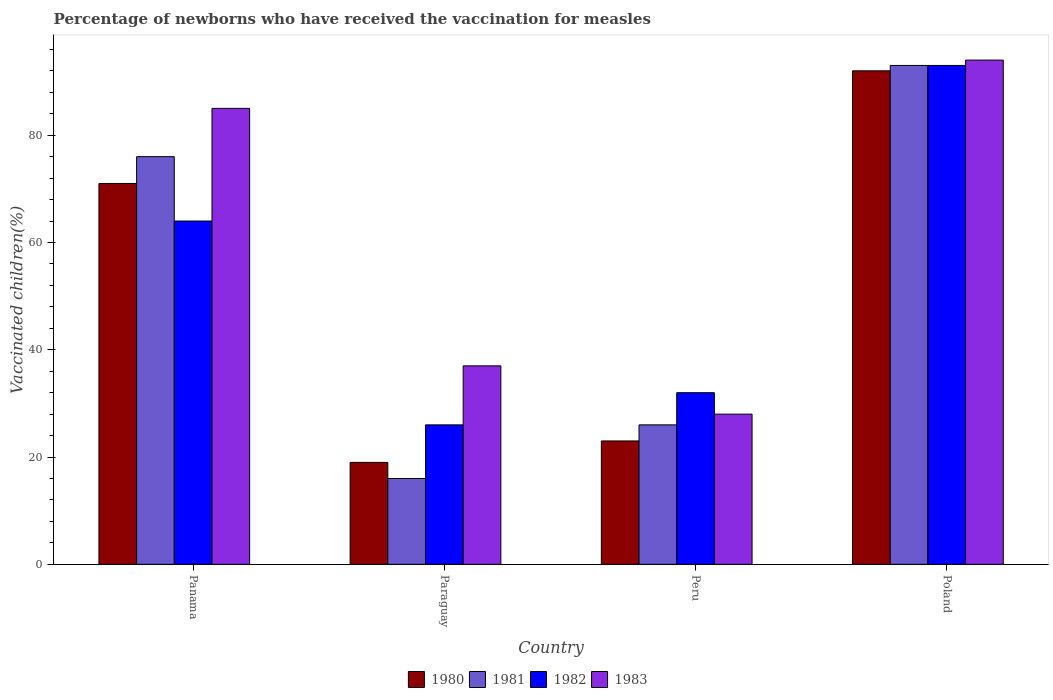How many groups of bars are there?
Your answer should be very brief. 4. Are the number of bars per tick equal to the number of legend labels?
Make the answer very short. Yes. How many bars are there on the 1st tick from the left?
Ensure brevity in your answer.  4. What is the label of the 2nd group of bars from the left?
Offer a terse response. Paraguay. In how many cases, is the number of bars for a given country not equal to the number of legend labels?
Offer a very short reply. 0. What is the percentage of vaccinated children in 1983 in Poland?
Your response must be concise. 94. Across all countries, what is the maximum percentage of vaccinated children in 1981?
Your answer should be very brief. 93. In which country was the percentage of vaccinated children in 1982 minimum?
Make the answer very short. Paraguay. What is the total percentage of vaccinated children in 1980 in the graph?
Your answer should be very brief. 205. What is the difference between the percentage of vaccinated children in 1980 in Panama and that in Peru?
Keep it short and to the point. 48. What is the difference between the percentage of vaccinated children in 1980 in Peru and the percentage of vaccinated children in 1983 in Poland?
Your response must be concise. -71. What is the difference between the percentage of vaccinated children of/in 1981 and percentage of vaccinated children of/in 1983 in Peru?
Make the answer very short. -2. In how many countries, is the percentage of vaccinated children in 1980 greater than 28 %?
Ensure brevity in your answer.  2. What is the ratio of the percentage of vaccinated children in 1980 in Panama to that in Peru?
Keep it short and to the point. 3.09. Is the difference between the percentage of vaccinated children in 1981 in Paraguay and Peru greater than the difference between the percentage of vaccinated children in 1983 in Paraguay and Peru?
Give a very brief answer. No. Is the sum of the percentage of vaccinated children in 1980 in Panama and Peru greater than the maximum percentage of vaccinated children in 1981 across all countries?
Provide a short and direct response. Yes. What does the 3rd bar from the left in Poland represents?
Make the answer very short. 1982. What does the 3rd bar from the right in Peru represents?
Your response must be concise. 1981. Is it the case that in every country, the sum of the percentage of vaccinated children in 1980 and percentage of vaccinated children in 1983 is greater than the percentage of vaccinated children in 1982?
Provide a short and direct response. Yes. How many bars are there?
Make the answer very short. 16. How many countries are there in the graph?
Offer a very short reply. 4. Are the values on the major ticks of Y-axis written in scientific E-notation?
Make the answer very short. No. How many legend labels are there?
Your response must be concise. 4. How are the legend labels stacked?
Offer a terse response. Horizontal. What is the title of the graph?
Give a very brief answer. Percentage of newborns who have received the vaccination for measles. What is the label or title of the Y-axis?
Offer a terse response. Vaccinated children(%). What is the Vaccinated children(%) in 1982 in Paraguay?
Offer a terse response. 26. What is the Vaccinated children(%) of 1980 in Peru?
Your answer should be compact. 23. What is the Vaccinated children(%) in 1981 in Peru?
Your response must be concise. 26. What is the Vaccinated children(%) of 1982 in Peru?
Give a very brief answer. 32. What is the Vaccinated children(%) in 1983 in Peru?
Offer a terse response. 28. What is the Vaccinated children(%) of 1980 in Poland?
Your answer should be very brief. 92. What is the Vaccinated children(%) of 1981 in Poland?
Provide a short and direct response. 93. What is the Vaccinated children(%) in 1982 in Poland?
Offer a terse response. 93. What is the Vaccinated children(%) of 1983 in Poland?
Your response must be concise. 94. Across all countries, what is the maximum Vaccinated children(%) in 1980?
Give a very brief answer. 92. Across all countries, what is the maximum Vaccinated children(%) in 1981?
Offer a terse response. 93. Across all countries, what is the maximum Vaccinated children(%) of 1982?
Your response must be concise. 93. Across all countries, what is the maximum Vaccinated children(%) of 1983?
Keep it short and to the point. 94. Across all countries, what is the minimum Vaccinated children(%) of 1981?
Offer a very short reply. 16. Across all countries, what is the minimum Vaccinated children(%) of 1982?
Your answer should be very brief. 26. Across all countries, what is the minimum Vaccinated children(%) of 1983?
Offer a very short reply. 28. What is the total Vaccinated children(%) in 1980 in the graph?
Make the answer very short. 205. What is the total Vaccinated children(%) in 1981 in the graph?
Offer a very short reply. 211. What is the total Vaccinated children(%) in 1982 in the graph?
Provide a short and direct response. 215. What is the total Vaccinated children(%) in 1983 in the graph?
Ensure brevity in your answer.  244. What is the difference between the Vaccinated children(%) of 1980 in Panama and that in Paraguay?
Provide a succinct answer. 52. What is the difference between the Vaccinated children(%) in 1982 in Panama and that in Paraguay?
Offer a very short reply. 38. What is the difference between the Vaccinated children(%) of 1980 in Panama and that in Peru?
Make the answer very short. 48. What is the difference between the Vaccinated children(%) in 1981 in Panama and that in Poland?
Your response must be concise. -17. What is the difference between the Vaccinated children(%) in 1983 in Panama and that in Poland?
Your answer should be very brief. -9. What is the difference between the Vaccinated children(%) in 1980 in Paraguay and that in Peru?
Keep it short and to the point. -4. What is the difference between the Vaccinated children(%) in 1981 in Paraguay and that in Peru?
Provide a succinct answer. -10. What is the difference between the Vaccinated children(%) in 1982 in Paraguay and that in Peru?
Your answer should be compact. -6. What is the difference between the Vaccinated children(%) in 1983 in Paraguay and that in Peru?
Ensure brevity in your answer.  9. What is the difference between the Vaccinated children(%) of 1980 in Paraguay and that in Poland?
Your answer should be compact. -73. What is the difference between the Vaccinated children(%) in 1981 in Paraguay and that in Poland?
Offer a very short reply. -77. What is the difference between the Vaccinated children(%) of 1982 in Paraguay and that in Poland?
Provide a short and direct response. -67. What is the difference between the Vaccinated children(%) of 1983 in Paraguay and that in Poland?
Give a very brief answer. -57. What is the difference between the Vaccinated children(%) of 1980 in Peru and that in Poland?
Provide a short and direct response. -69. What is the difference between the Vaccinated children(%) in 1981 in Peru and that in Poland?
Keep it short and to the point. -67. What is the difference between the Vaccinated children(%) in 1982 in Peru and that in Poland?
Your answer should be compact. -61. What is the difference between the Vaccinated children(%) in 1983 in Peru and that in Poland?
Ensure brevity in your answer.  -66. What is the difference between the Vaccinated children(%) in 1980 in Panama and the Vaccinated children(%) in 1981 in Paraguay?
Offer a terse response. 55. What is the difference between the Vaccinated children(%) of 1980 in Panama and the Vaccinated children(%) of 1982 in Paraguay?
Offer a very short reply. 45. What is the difference between the Vaccinated children(%) of 1981 in Panama and the Vaccinated children(%) of 1983 in Paraguay?
Make the answer very short. 39. What is the difference between the Vaccinated children(%) of 1982 in Panama and the Vaccinated children(%) of 1983 in Paraguay?
Your answer should be compact. 27. What is the difference between the Vaccinated children(%) in 1980 in Panama and the Vaccinated children(%) in 1982 in Peru?
Offer a very short reply. 39. What is the difference between the Vaccinated children(%) in 1981 in Panama and the Vaccinated children(%) in 1982 in Peru?
Provide a succinct answer. 44. What is the difference between the Vaccinated children(%) in 1980 in Panama and the Vaccinated children(%) in 1983 in Poland?
Keep it short and to the point. -23. What is the difference between the Vaccinated children(%) in 1981 in Panama and the Vaccinated children(%) in 1982 in Poland?
Your response must be concise. -17. What is the difference between the Vaccinated children(%) of 1981 in Panama and the Vaccinated children(%) of 1983 in Poland?
Your answer should be compact. -18. What is the difference between the Vaccinated children(%) in 1982 in Panama and the Vaccinated children(%) in 1983 in Poland?
Your answer should be compact. -30. What is the difference between the Vaccinated children(%) of 1980 in Paraguay and the Vaccinated children(%) of 1981 in Peru?
Your answer should be very brief. -7. What is the difference between the Vaccinated children(%) of 1981 in Paraguay and the Vaccinated children(%) of 1982 in Peru?
Give a very brief answer. -16. What is the difference between the Vaccinated children(%) in 1981 in Paraguay and the Vaccinated children(%) in 1983 in Peru?
Your answer should be compact. -12. What is the difference between the Vaccinated children(%) of 1980 in Paraguay and the Vaccinated children(%) of 1981 in Poland?
Give a very brief answer. -74. What is the difference between the Vaccinated children(%) of 1980 in Paraguay and the Vaccinated children(%) of 1982 in Poland?
Give a very brief answer. -74. What is the difference between the Vaccinated children(%) of 1980 in Paraguay and the Vaccinated children(%) of 1983 in Poland?
Give a very brief answer. -75. What is the difference between the Vaccinated children(%) in 1981 in Paraguay and the Vaccinated children(%) in 1982 in Poland?
Your answer should be very brief. -77. What is the difference between the Vaccinated children(%) of 1981 in Paraguay and the Vaccinated children(%) of 1983 in Poland?
Keep it short and to the point. -78. What is the difference between the Vaccinated children(%) in 1982 in Paraguay and the Vaccinated children(%) in 1983 in Poland?
Provide a succinct answer. -68. What is the difference between the Vaccinated children(%) of 1980 in Peru and the Vaccinated children(%) of 1981 in Poland?
Your answer should be compact. -70. What is the difference between the Vaccinated children(%) in 1980 in Peru and the Vaccinated children(%) in 1982 in Poland?
Ensure brevity in your answer.  -70. What is the difference between the Vaccinated children(%) in 1980 in Peru and the Vaccinated children(%) in 1983 in Poland?
Ensure brevity in your answer.  -71. What is the difference between the Vaccinated children(%) in 1981 in Peru and the Vaccinated children(%) in 1982 in Poland?
Ensure brevity in your answer.  -67. What is the difference between the Vaccinated children(%) of 1981 in Peru and the Vaccinated children(%) of 1983 in Poland?
Offer a very short reply. -68. What is the difference between the Vaccinated children(%) in 1982 in Peru and the Vaccinated children(%) in 1983 in Poland?
Offer a very short reply. -62. What is the average Vaccinated children(%) of 1980 per country?
Your answer should be very brief. 51.25. What is the average Vaccinated children(%) in 1981 per country?
Provide a succinct answer. 52.75. What is the average Vaccinated children(%) in 1982 per country?
Give a very brief answer. 53.75. What is the average Vaccinated children(%) of 1983 per country?
Offer a very short reply. 61. What is the difference between the Vaccinated children(%) in 1980 and Vaccinated children(%) in 1981 in Panama?
Offer a very short reply. -5. What is the difference between the Vaccinated children(%) of 1981 and Vaccinated children(%) of 1982 in Panama?
Offer a very short reply. 12. What is the difference between the Vaccinated children(%) in 1981 and Vaccinated children(%) in 1983 in Panama?
Keep it short and to the point. -9. What is the difference between the Vaccinated children(%) in 1982 and Vaccinated children(%) in 1983 in Panama?
Make the answer very short. -21. What is the difference between the Vaccinated children(%) in 1980 and Vaccinated children(%) in 1981 in Paraguay?
Make the answer very short. 3. What is the difference between the Vaccinated children(%) of 1980 and Vaccinated children(%) of 1982 in Paraguay?
Ensure brevity in your answer.  -7. What is the difference between the Vaccinated children(%) in 1981 and Vaccinated children(%) in 1982 in Paraguay?
Make the answer very short. -10. What is the difference between the Vaccinated children(%) of 1982 and Vaccinated children(%) of 1983 in Paraguay?
Offer a very short reply. -11. What is the difference between the Vaccinated children(%) in 1980 and Vaccinated children(%) in 1983 in Peru?
Provide a short and direct response. -5. What is the difference between the Vaccinated children(%) of 1981 and Vaccinated children(%) of 1983 in Peru?
Ensure brevity in your answer.  -2. What is the difference between the Vaccinated children(%) in 1981 and Vaccinated children(%) in 1982 in Poland?
Offer a terse response. 0. What is the difference between the Vaccinated children(%) of 1981 and Vaccinated children(%) of 1983 in Poland?
Offer a terse response. -1. What is the ratio of the Vaccinated children(%) of 1980 in Panama to that in Paraguay?
Your response must be concise. 3.74. What is the ratio of the Vaccinated children(%) in 1981 in Panama to that in Paraguay?
Provide a succinct answer. 4.75. What is the ratio of the Vaccinated children(%) of 1982 in Panama to that in Paraguay?
Provide a short and direct response. 2.46. What is the ratio of the Vaccinated children(%) of 1983 in Panama to that in Paraguay?
Your response must be concise. 2.3. What is the ratio of the Vaccinated children(%) of 1980 in Panama to that in Peru?
Provide a short and direct response. 3.09. What is the ratio of the Vaccinated children(%) in 1981 in Panama to that in Peru?
Provide a short and direct response. 2.92. What is the ratio of the Vaccinated children(%) of 1983 in Panama to that in Peru?
Provide a succinct answer. 3.04. What is the ratio of the Vaccinated children(%) in 1980 in Panama to that in Poland?
Offer a very short reply. 0.77. What is the ratio of the Vaccinated children(%) in 1981 in Panama to that in Poland?
Offer a terse response. 0.82. What is the ratio of the Vaccinated children(%) of 1982 in Panama to that in Poland?
Your answer should be very brief. 0.69. What is the ratio of the Vaccinated children(%) in 1983 in Panama to that in Poland?
Make the answer very short. 0.9. What is the ratio of the Vaccinated children(%) of 1980 in Paraguay to that in Peru?
Provide a succinct answer. 0.83. What is the ratio of the Vaccinated children(%) of 1981 in Paraguay to that in Peru?
Give a very brief answer. 0.62. What is the ratio of the Vaccinated children(%) in 1982 in Paraguay to that in Peru?
Provide a short and direct response. 0.81. What is the ratio of the Vaccinated children(%) of 1983 in Paraguay to that in Peru?
Keep it short and to the point. 1.32. What is the ratio of the Vaccinated children(%) in 1980 in Paraguay to that in Poland?
Give a very brief answer. 0.21. What is the ratio of the Vaccinated children(%) in 1981 in Paraguay to that in Poland?
Provide a succinct answer. 0.17. What is the ratio of the Vaccinated children(%) in 1982 in Paraguay to that in Poland?
Your answer should be very brief. 0.28. What is the ratio of the Vaccinated children(%) in 1983 in Paraguay to that in Poland?
Make the answer very short. 0.39. What is the ratio of the Vaccinated children(%) of 1981 in Peru to that in Poland?
Offer a terse response. 0.28. What is the ratio of the Vaccinated children(%) of 1982 in Peru to that in Poland?
Your response must be concise. 0.34. What is the ratio of the Vaccinated children(%) in 1983 in Peru to that in Poland?
Make the answer very short. 0.3. What is the difference between the highest and the second highest Vaccinated children(%) of 1980?
Your response must be concise. 21. What is the difference between the highest and the second highest Vaccinated children(%) in 1981?
Provide a succinct answer. 17. What is the difference between the highest and the second highest Vaccinated children(%) of 1982?
Ensure brevity in your answer.  29. What is the difference between the highest and the second highest Vaccinated children(%) in 1983?
Your answer should be compact. 9. What is the difference between the highest and the lowest Vaccinated children(%) in 1981?
Your answer should be compact. 77. What is the difference between the highest and the lowest Vaccinated children(%) of 1983?
Provide a short and direct response. 66. 